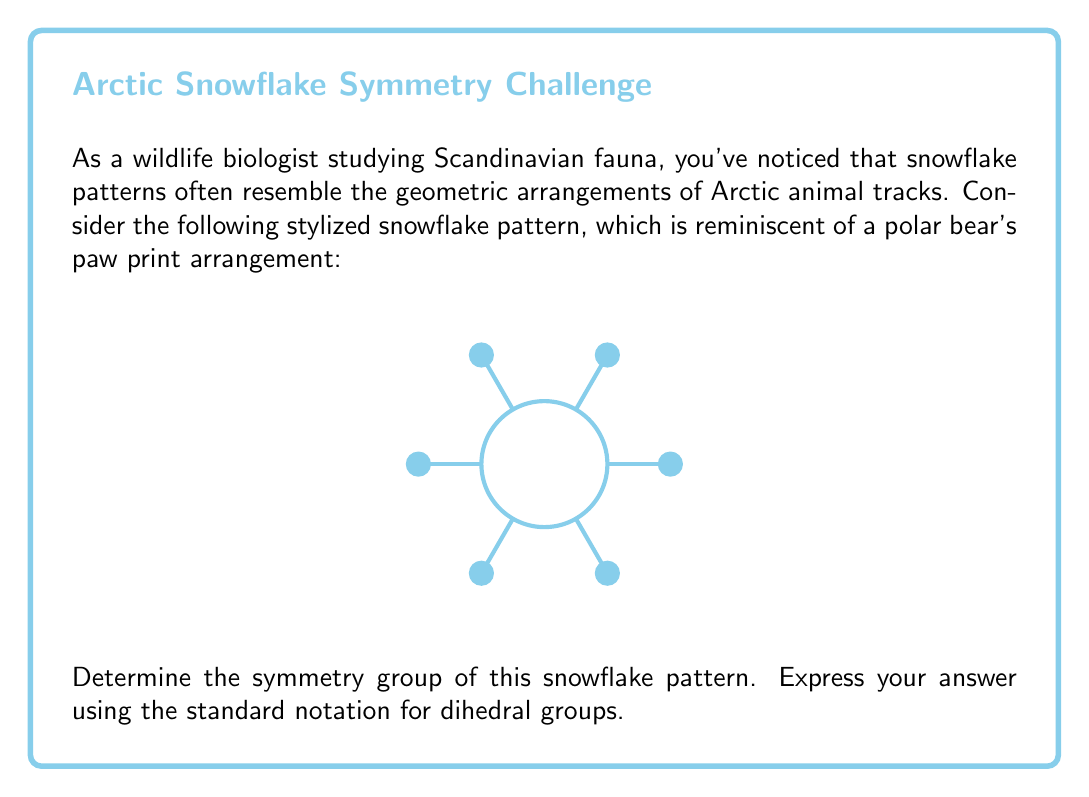Help me with this question. To determine the symmetry group of this snowflake pattern, let's analyze its symmetries step-by-step:

1) Rotational symmetries:
   - The snowflake has 6-fold rotational symmetry, meaning it can be rotated by multiples of 60° (or $\frac{\pi}{3}$ radians) and remain unchanged.
   - There are 6 distinct rotations: 0°, 60°, 120°, 180°, 240°, and 300°.

2) Reflection symmetries:
   - The snowflake has 6 lines of reflection symmetry:
     * 3 lines passing through opposite vertices
     * 3 lines passing through the midpoints of opposite sides

3) Identity symmetry:
   - The identity transformation (doing nothing) is always a symmetry.

4) Total number of symmetries:
   - 6 rotations + 6 reflections + 1 identity = 13 symmetries

5) Group structure:
   - This combination of rotations and reflections forms a dihedral group.
   - The order of the group is 12, which corresponds to the dihedral group $D_6$.

6) Properties of $D_6$:
   - It has 12 elements: 6 rotations and 6 reflections.
   - It is non-abelian (rotations and reflections don't always commute).
   - It can be generated by a rotation of order 6 and a reflection.

Therefore, the symmetry group of this snowflake pattern is isomorphic to the dihedral group $D_6$.
Answer: $D_6$ 